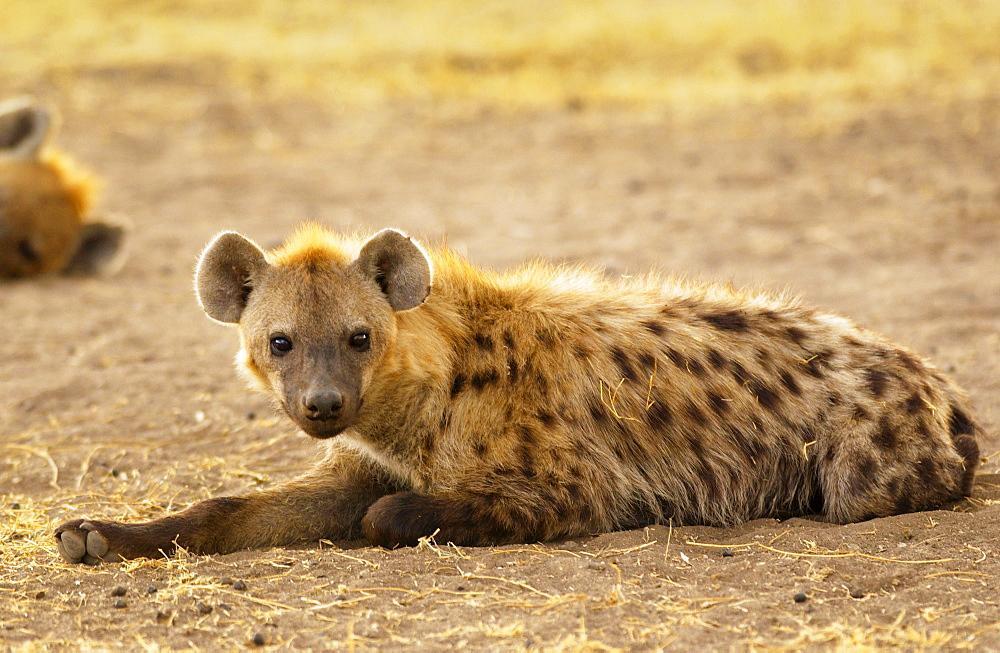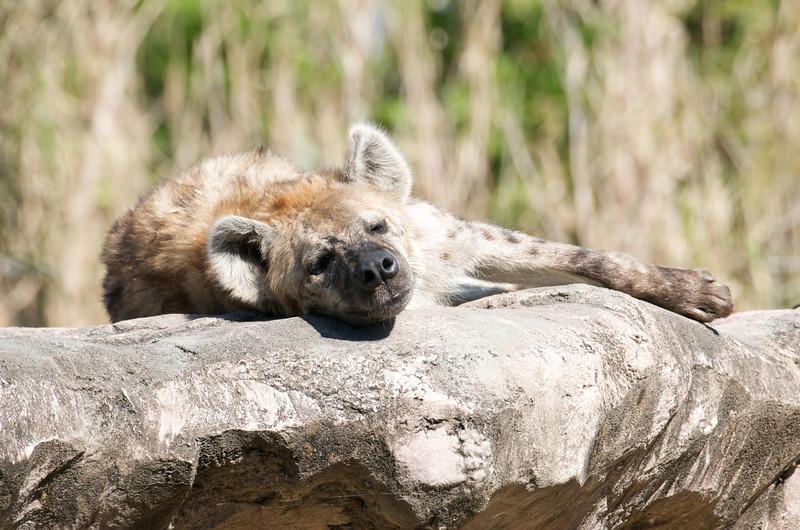The first image is the image on the left, the second image is the image on the right. Examine the images to the left and right. Is the description "The animal in one of the images has its head laying directly on the ground." accurate? Answer yes or no. No. 